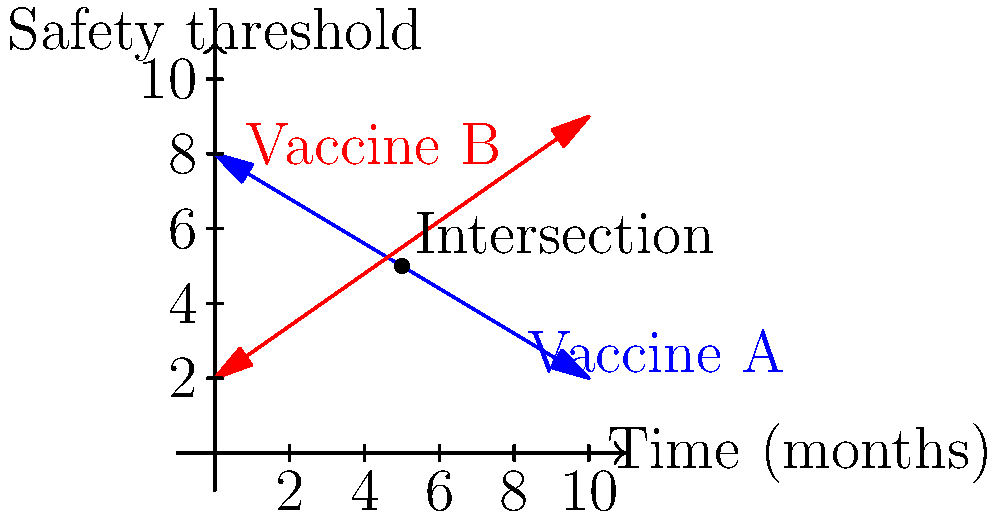Two vaccines, A and B, are being evaluated for safety over time. The safety threshold for Vaccine A is represented by the equation $y = -0.6x + 8$, while Vaccine B's safety threshold is given by $y = 0.7x + 2$, where $x$ represents time in months and $y$ represents the safety threshold. At what point in time do these two vaccines have the same safety threshold, and what is that threshold value? To find the intersection point of the two lines, we need to solve the system of equations:

1) For Vaccine A: $y = -0.6x + 8$
2) For Vaccine B: $y = 0.7x + 2$

At the intersection point, the $y$ values are equal, so we can set the equations equal to each other:

3) $-0.6x + 8 = 0.7x + 2$

Now, let's solve for $x$:

4) $-0.6x - 0.7x = 2 - 8$
5) $-1.3x = -6$
6) $x = \frac{-6}{-1.3} = \frac{6}{1.3} \approx 4.62$ months

To find the $y$ value (safety threshold) at this point, we can substitute this $x$ value into either of the original equations. Let's use Vaccine A's equation:

7) $y = -0.6(4.62) + 8$
8) $y = -2.772 + 8 = 5.228$

Therefore, the two vaccines have the same safety threshold approximately 4.62 months after the start of the evaluation, and the safety threshold at this point is approximately 5.23.
Answer: (4.62, 5.23) 